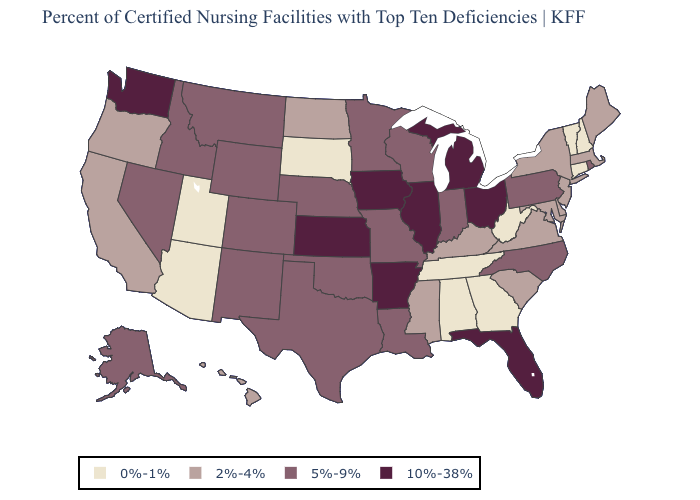Among the states that border Michigan , does Wisconsin have the lowest value?
Answer briefly. Yes. Name the states that have a value in the range 5%-9%?
Concise answer only. Alaska, Colorado, Idaho, Indiana, Louisiana, Minnesota, Missouri, Montana, Nebraska, Nevada, New Mexico, North Carolina, Oklahoma, Pennsylvania, Rhode Island, Texas, Wisconsin, Wyoming. What is the value of Arizona?
Concise answer only. 0%-1%. Name the states that have a value in the range 5%-9%?
Answer briefly. Alaska, Colorado, Idaho, Indiana, Louisiana, Minnesota, Missouri, Montana, Nebraska, Nevada, New Mexico, North Carolina, Oklahoma, Pennsylvania, Rhode Island, Texas, Wisconsin, Wyoming. What is the lowest value in states that border Louisiana?
Concise answer only. 2%-4%. What is the highest value in the MidWest ?
Keep it brief. 10%-38%. Does Missouri have the highest value in the USA?
Quick response, please. No. What is the highest value in states that border Missouri?
Give a very brief answer. 10%-38%. What is the value of Montana?
Be succinct. 5%-9%. Name the states that have a value in the range 5%-9%?
Short answer required. Alaska, Colorado, Idaho, Indiana, Louisiana, Minnesota, Missouri, Montana, Nebraska, Nevada, New Mexico, North Carolina, Oklahoma, Pennsylvania, Rhode Island, Texas, Wisconsin, Wyoming. What is the lowest value in the MidWest?
Give a very brief answer. 0%-1%. What is the lowest value in states that border Washington?
Answer briefly. 2%-4%. Does Georgia have a lower value than Florida?
Quick response, please. Yes. Name the states that have a value in the range 2%-4%?
Write a very short answer. California, Delaware, Hawaii, Kentucky, Maine, Maryland, Massachusetts, Mississippi, New Jersey, New York, North Dakota, Oregon, South Carolina, Virginia. Among the states that border West Virginia , which have the lowest value?
Answer briefly. Kentucky, Maryland, Virginia. 